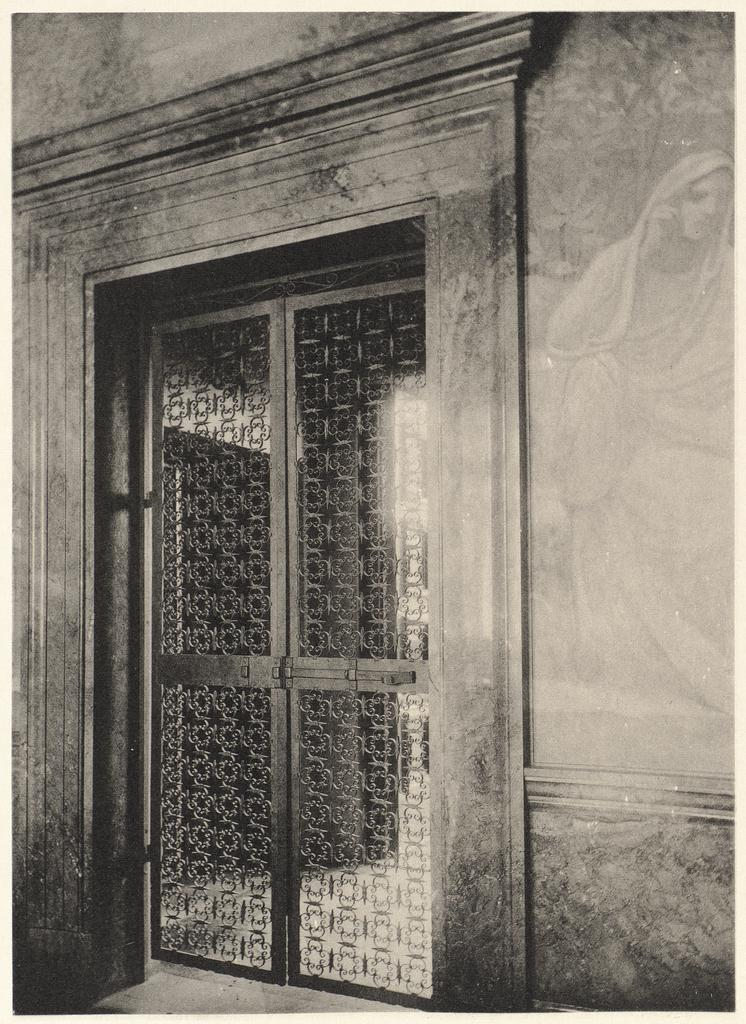What is hanging on the wall in the image? There is a painting on the wall in the image. What structure can be seen in the image? There is a gate in the image. What type of apparatus is being used by the chickens in the image? There are no chickens or apparatus present in the image. Who is the friend standing next to the gate in the image? There is no friend or person visible in the image; only a gate and a painting on the wall are present. 